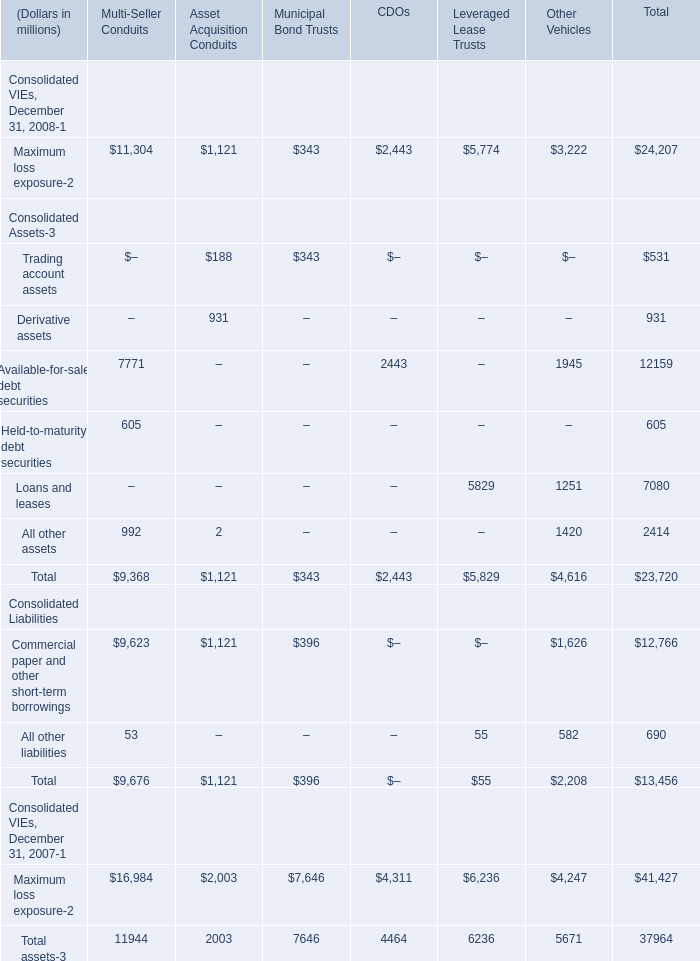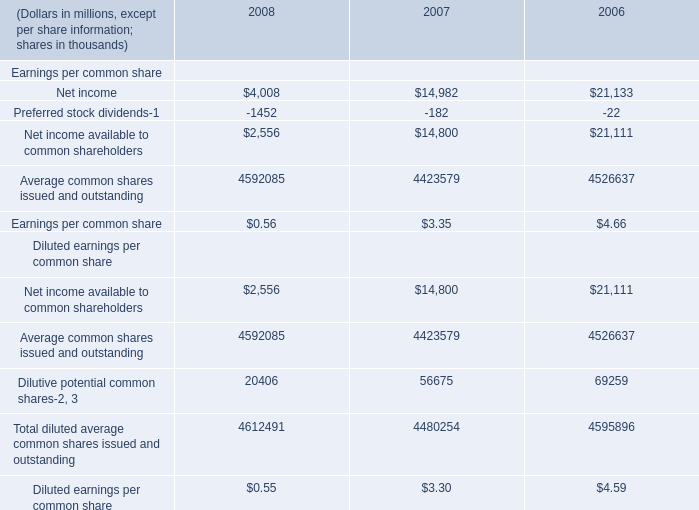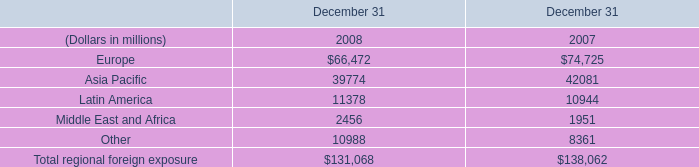What is the average amount of Other of December 31 2008, and Average common shares issued and outstanding of 2006 ? 
Computations: ((10988.0 + 4526637.0) / 2)
Answer: 2268812.5. 